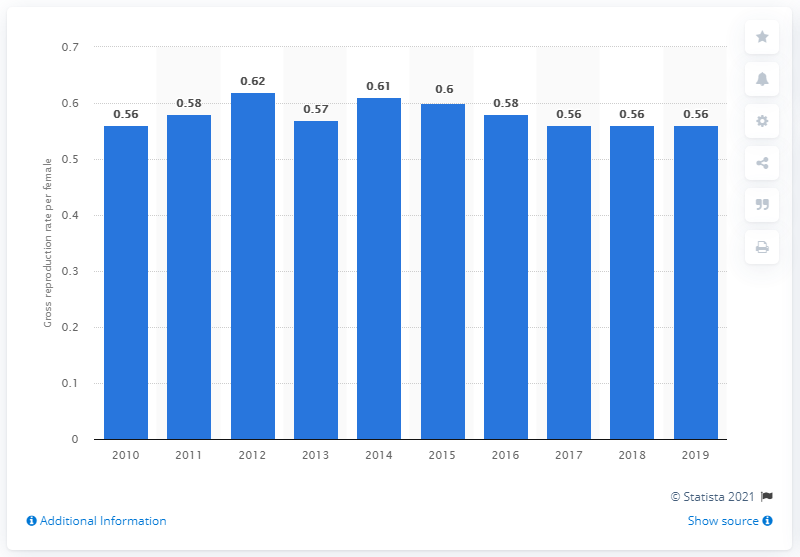Draw attention to some important aspects in this diagram. Singapore's gross reproduction rate in 2019 was 0.56. 